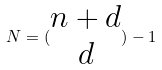Convert formula to latex. <formula><loc_0><loc_0><loc_500><loc_500>N = ( \begin{matrix} n + d \\ d \end{matrix} ) - 1</formula> 